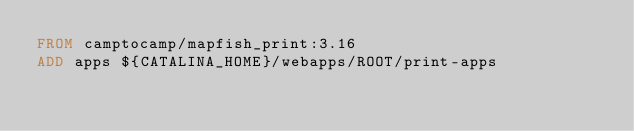<code> <loc_0><loc_0><loc_500><loc_500><_Dockerfile_>FROM camptocamp/mapfish_print:3.16
ADD apps ${CATALINA_HOME}/webapps/ROOT/print-apps</code> 